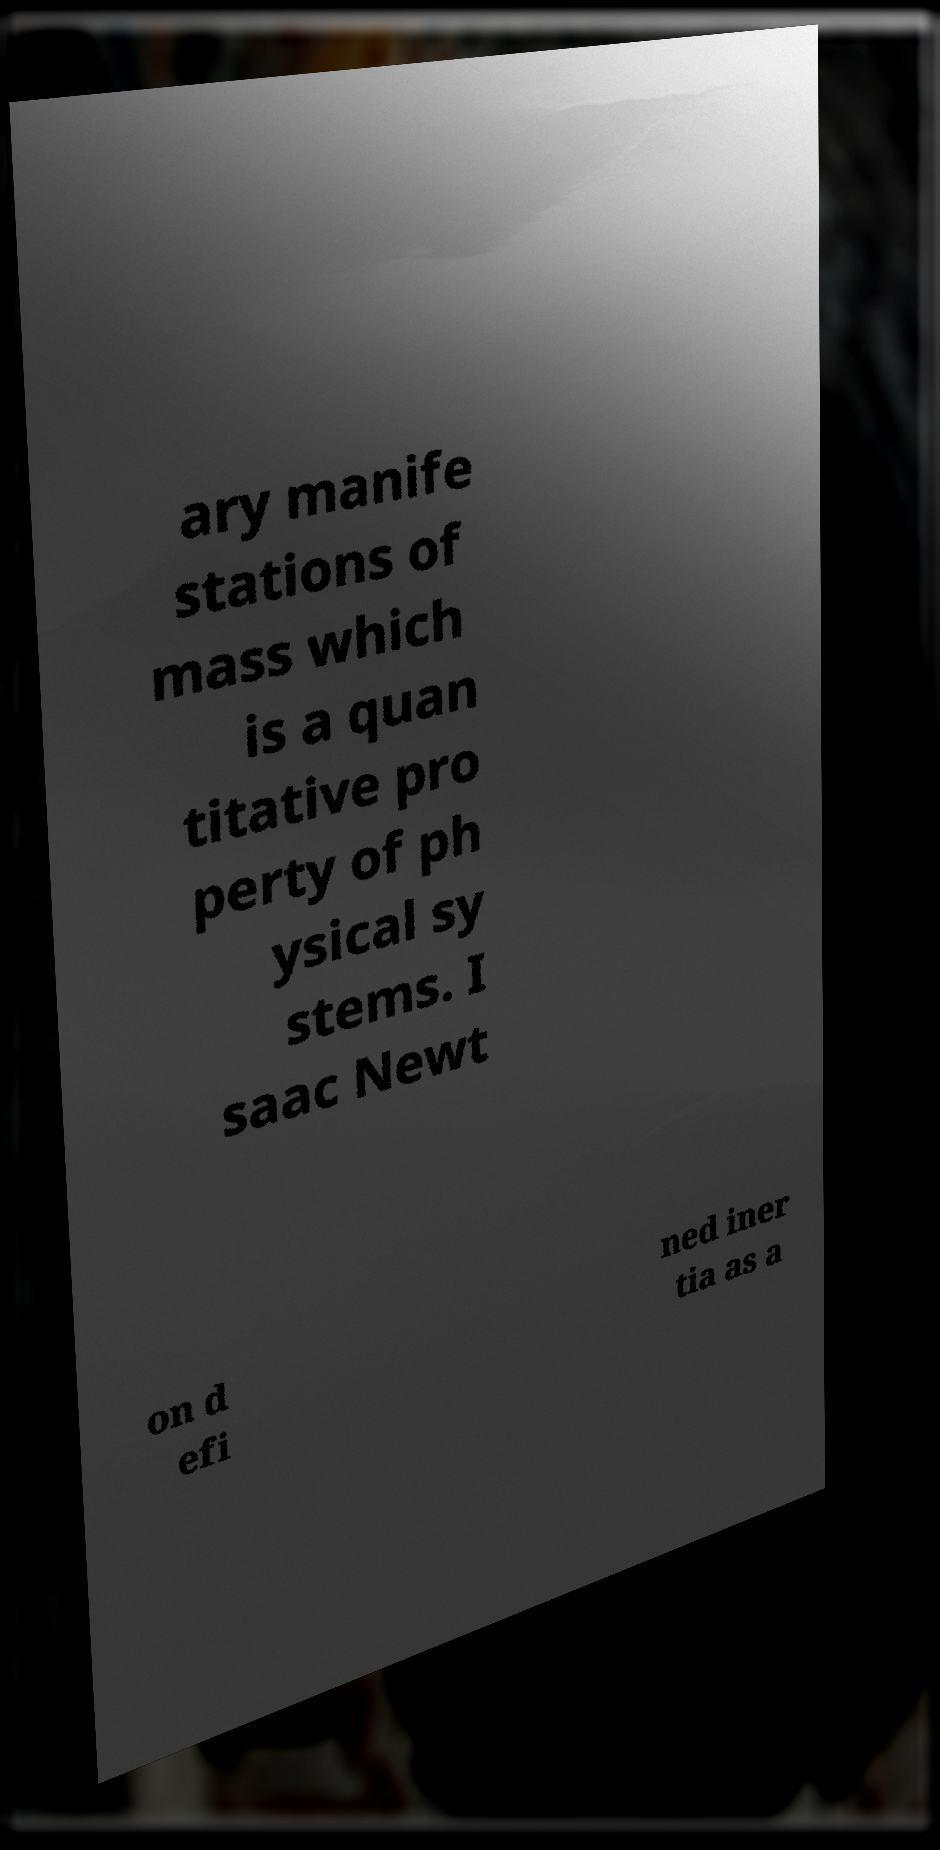For documentation purposes, I need the text within this image transcribed. Could you provide that? ary manife stations of mass which is a quan titative pro perty of ph ysical sy stems. I saac Newt on d efi ned iner tia as a 